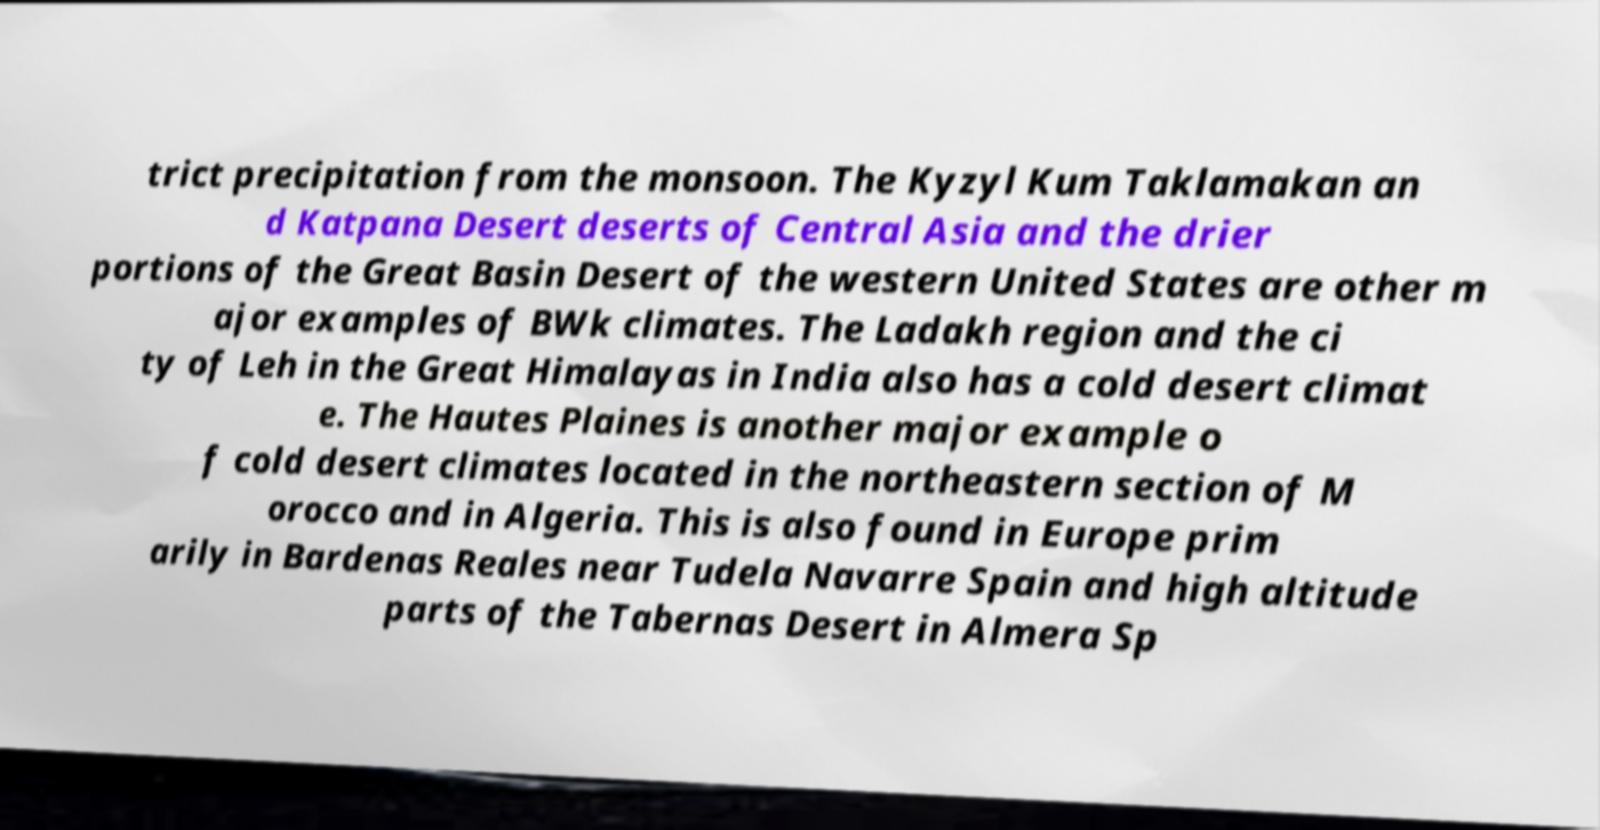Please read and relay the text visible in this image. What does it say? trict precipitation from the monsoon. The Kyzyl Kum Taklamakan an d Katpana Desert deserts of Central Asia and the drier portions of the Great Basin Desert of the western United States are other m ajor examples of BWk climates. The Ladakh region and the ci ty of Leh in the Great Himalayas in India also has a cold desert climat e. The Hautes Plaines is another major example o f cold desert climates located in the northeastern section of M orocco and in Algeria. This is also found in Europe prim arily in Bardenas Reales near Tudela Navarre Spain and high altitude parts of the Tabernas Desert in Almera Sp 